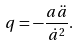Convert formula to latex. <formula><loc_0><loc_0><loc_500><loc_500>q = - \frac { a \ddot { a } } { \dot { a } ^ { 2 } } .</formula> 